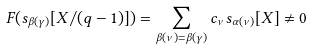Convert formula to latex. <formula><loc_0><loc_0><loc_500><loc_500>F ( s _ { \beta ( \gamma ) } [ X / ( q - 1 ) ] ) = \sum _ { \beta ( \nu ) = \beta ( \gamma ) } c _ { \nu } s _ { \alpha ( \nu ) } [ X ] \not = 0</formula> 